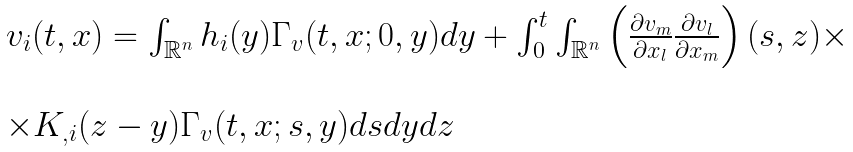Convert formula to latex. <formula><loc_0><loc_0><loc_500><loc_500>\begin{array} { l l } v _ { i } ( t , x ) = \int _ { { \mathbb { R } } ^ { n } } h _ { i } ( y ) \Gamma _ { v } ( t , x ; 0 , y ) d y + \int _ { 0 } ^ { t } \int _ { { \mathbb { R } } ^ { n } } \left ( \frac { \partial v _ { m } } { \partial x _ { l } } \frac { \partial v _ { l } } { \partial x _ { m } } \right ) ( s , z ) \times \\ \\ \times K _ { , i } ( z - y ) \Gamma _ { v } ( t , x ; s , y ) d s d y d z \end{array}</formula> 